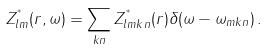Convert formula to latex. <formula><loc_0><loc_0><loc_500><loc_500>Z ^ { ^ { * } } _ { l m } ( r , \omega ) = \sum _ { k n } Z ^ { ^ { * } } _ { l m k n } ( r ) \delta ( \omega - \omega _ { m k n } ) \, .</formula> 